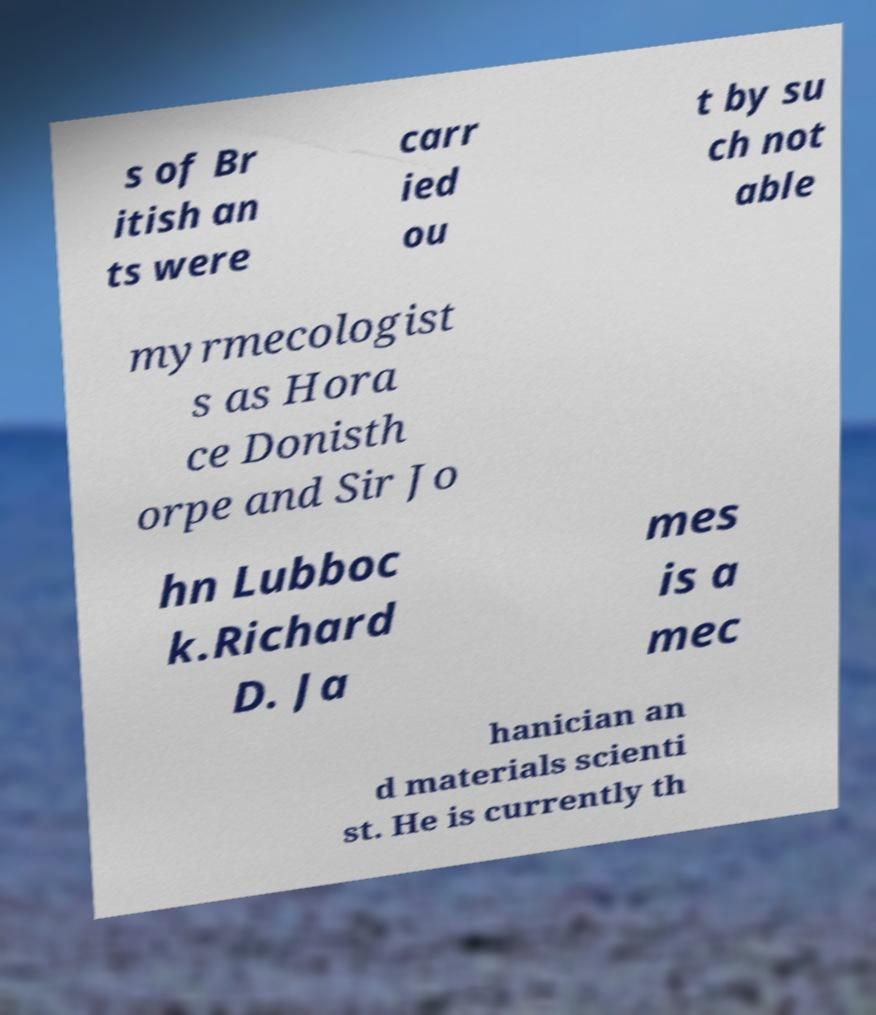Could you assist in decoding the text presented in this image and type it out clearly? s of Br itish an ts were carr ied ou t by su ch not able myrmecologist s as Hora ce Donisth orpe and Sir Jo hn Lubboc k.Richard D. Ja mes is a mec hanician an d materials scienti st. He is currently th 